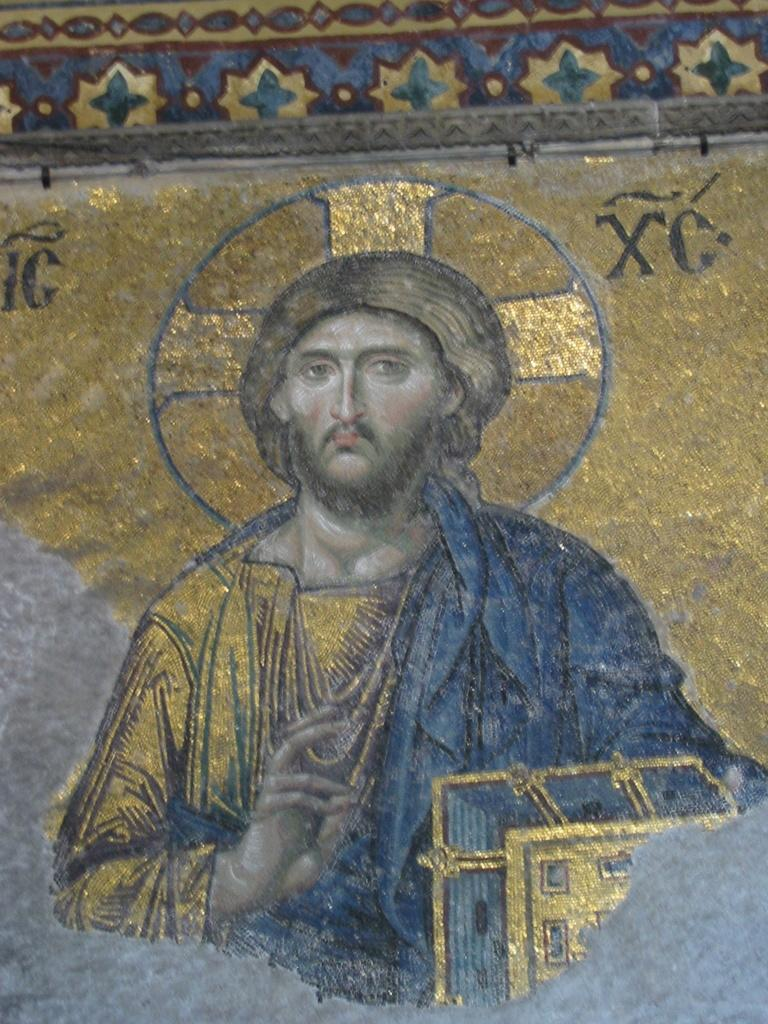What is the main subject of the image? There is a picture of Jesus Christ in the image. What type of bun is being used to represent wealth in the image? There is no bun or representation of wealth present in the image; it features a picture of Jesus Christ. 